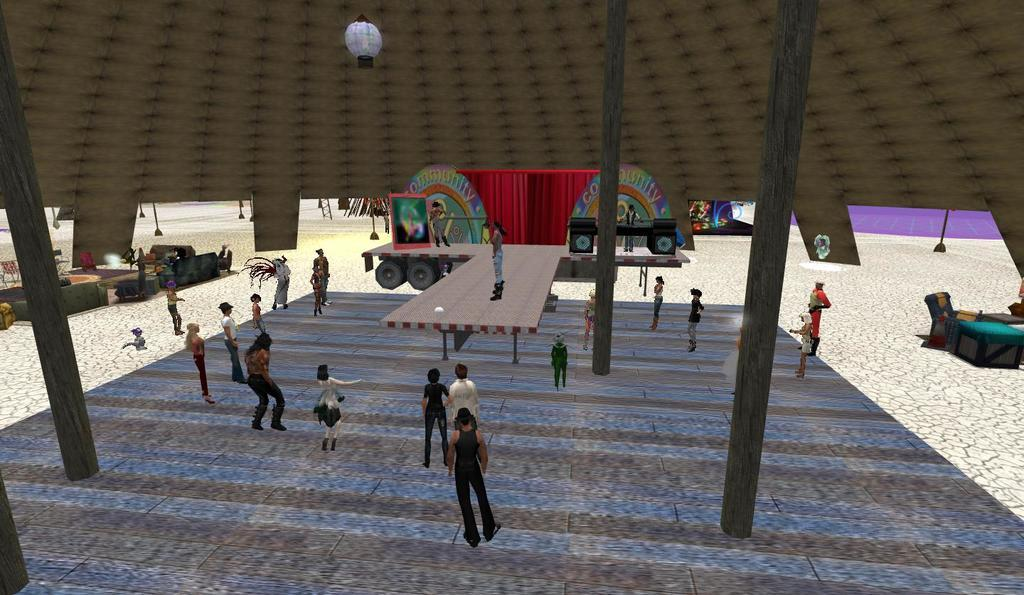What type of image is being depicted? The image is of a computer game. What kind of characters are present in the game? There are anime characters in the game. What are the anime characters doing? The anime characters are standing. What is the setting of the game? There is a stage in the game. What is happening on the stage? A rock band is on the stage. Are there any other structures or objects in the game? Yes, there is a tent in the game. How is the tent being illuminated? There is light on the tent. What type of celery is being used as a microphone by the lead singer of the rock band? There is no celery present in the image, and the lead singer is not using any vegetables as a microphone. 